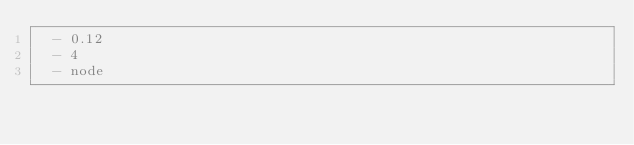Convert code to text. <code><loc_0><loc_0><loc_500><loc_500><_YAML_>  - 0.12
  - 4
  - node
</code> 